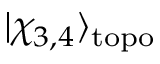Convert formula to latex. <formula><loc_0><loc_0><loc_500><loc_500>| \chi _ { 3 , 4 } \rangle _ { t o p o }</formula> 